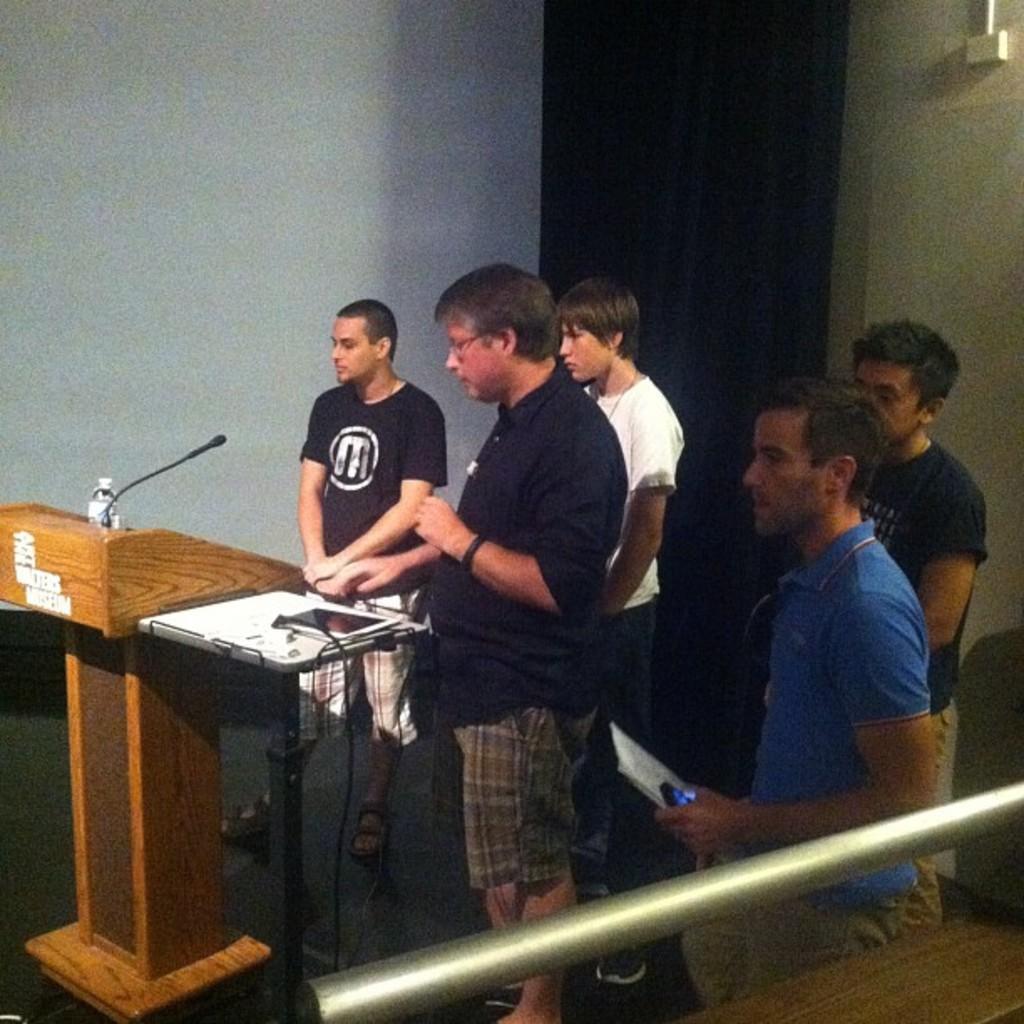Could you give a brief overview of what you see in this image? This image is clicked inside. In this there are five men standing. To the left, there is a podium on which a mic and a bottle are kept. In the background, there is a wall and curtain. In the front, the man is wearing blue t-shirt. At the bottom, there is a floor. 